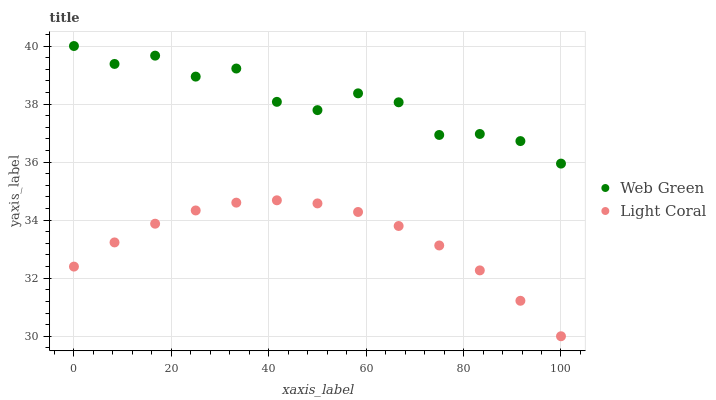Does Light Coral have the minimum area under the curve?
Answer yes or no. Yes. Does Web Green have the maximum area under the curve?
Answer yes or no. Yes. Does Web Green have the minimum area under the curve?
Answer yes or no. No. Is Light Coral the smoothest?
Answer yes or no. Yes. Is Web Green the roughest?
Answer yes or no. Yes. Is Web Green the smoothest?
Answer yes or no. No. Does Light Coral have the lowest value?
Answer yes or no. Yes. Does Web Green have the lowest value?
Answer yes or no. No. Does Web Green have the highest value?
Answer yes or no. Yes. Is Light Coral less than Web Green?
Answer yes or no. Yes. Is Web Green greater than Light Coral?
Answer yes or no. Yes. Does Light Coral intersect Web Green?
Answer yes or no. No. 